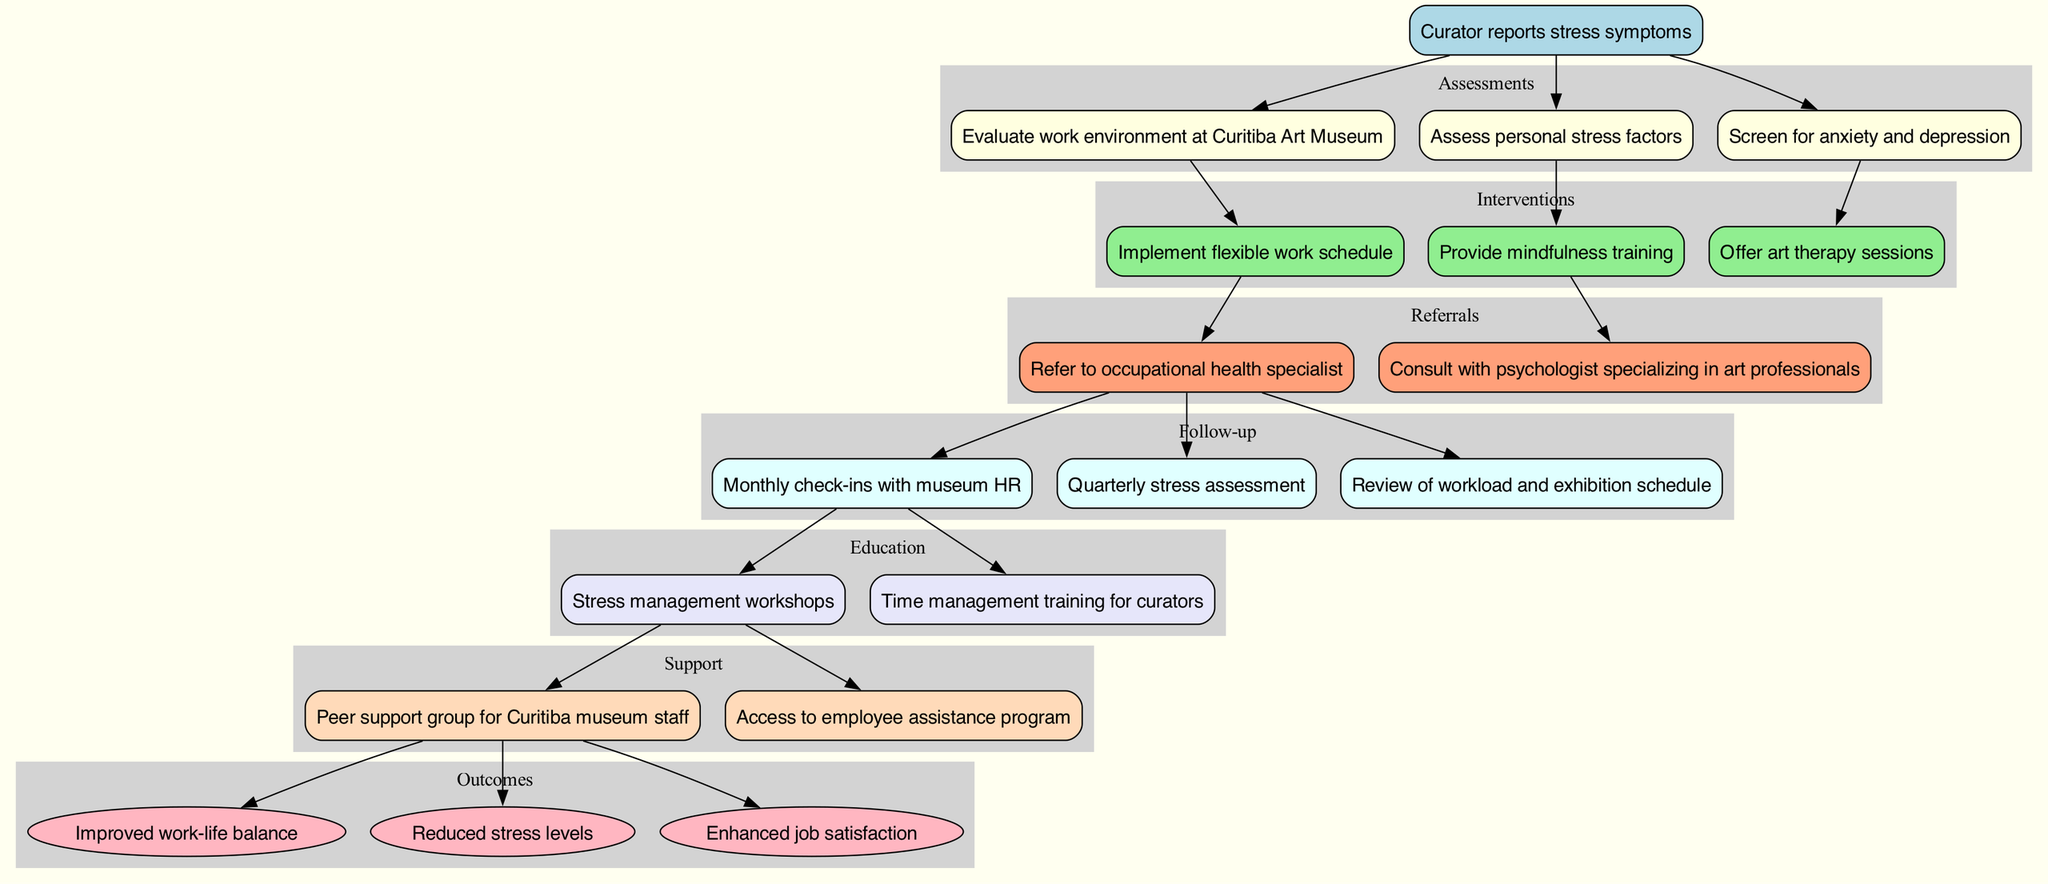What triggers the clinical pathway? The pathway starts when a curator reports stress symptoms, indicating that intervention is needed. This is the only entry point in the diagram.
Answer: Curator reports stress symptoms How many assessments are listed? There are three assessments mentioned in the diagram, which include evaluating the work environment, assessing personal stress factors, and screening for anxiety and depression.
Answer: 3 What is the first intervention after assessments? The first intervention following the assessments is implementing a flexible work schedule, which is the initial action taken based on the assessment outcomes.
Answer: Implement flexible work schedule Which referral is made first in the pathway? The first referral is made to the occupational health specialist, indicating a professional route taken after the interventions that were implemented.
Answer: Refer to occupational health specialist What type of outcomes are expected? The expected outcomes from the pathway focus on improved work-life balance, reduced stress levels, and enhanced job satisfaction, highlighting the goals of these interventions.
Answer: Improved work-life balance How are education and support grouped in the diagram? Education and support are both grouped in their own separate subgraphs within the pathway, indicating that they are additional components that follow the main interventions.
Answer: Two separate subgraphs How does the follow-up relate to the referrals? The follow-up actions are connected to the first referral made, which suggests that after a referral, regular check-ins and assessments are essential to ensure ongoing support and evaluation.
Answer: Connected to the first referral What color indicates the support section in the diagram? The support section is colored peachpuff in the diagram, distinguishing it visually from other sections for easier identification.
Answer: Peachpuff How many outcomes are illustrated at the end of the pathway? There are three outcomes illustrated at the end of the pathway, summarizing the potential benefits of the clinical pathway for the curator's stress management.
Answer: 3 